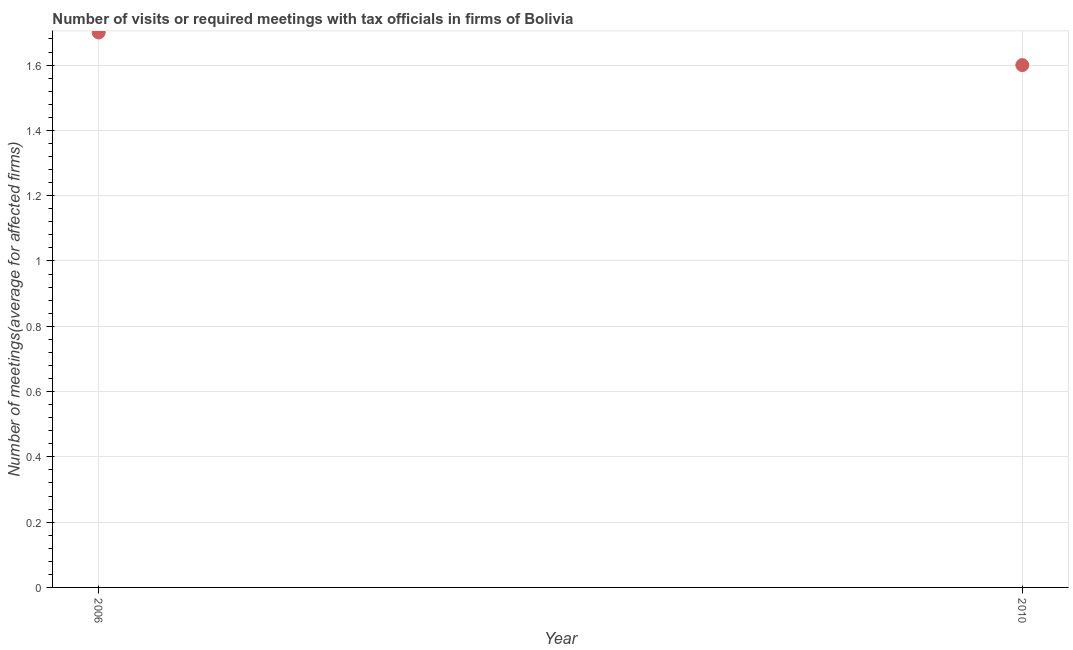What is the number of required meetings with tax officials in 2010?
Give a very brief answer. 1.6. Across all years, what is the maximum number of required meetings with tax officials?
Make the answer very short. 1.7. In which year was the number of required meetings with tax officials maximum?
Your response must be concise. 2006. In which year was the number of required meetings with tax officials minimum?
Provide a succinct answer. 2010. What is the difference between the number of required meetings with tax officials in 2006 and 2010?
Ensure brevity in your answer.  0.1. What is the average number of required meetings with tax officials per year?
Your response must be concise. 1.65. What is the median number of required meetings with tax officials?
Offer a terse response. 1.65. Do a majority of the years between 2006 and 2010 (inclusive) have number of required meetings with tax officials greater than 0.2 ?
Your response must be concise. Yes. How many dotlines are there?
Your answer should be very brief. 1. How many years are there in the graph?
Provide a succinct answer. 2. What is the difference between two consecutive major ticks on the Y-axis?
Keep it short and to the point. 0.2. Are the values on the major ticks of Y-axis written in scientific E-notation?
Give a very brief answer. No. Does the graph contain any zero values?
Your response must be concise. No. What is the title of the graph?
Your answer should be compact. Number of visits or required meetings with tax officials in firms of Bolivia. What is the label or title of the Y-axis?
Provide a short and direct response. Number of meetings(average for affected firms). What is the Number of meetings(average for affected firms) in 2006?
Make the answer very short. 1.7. What is the difference between the Number of meetings(average for affected firms) in 2006 and 2010?
Provide a succinct answer. 0.1. What is the ratio of the Number of meetings(average for affected firms) in 2006 to that in 2010?
Your answer should be very brief. 1.06. 